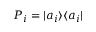Convert formula to latex. <formula><loc_0><loc_0><loc_500><loc_500>P _ { i } = | a _ { i } \rangle \langle a _ { i } |</formula> 